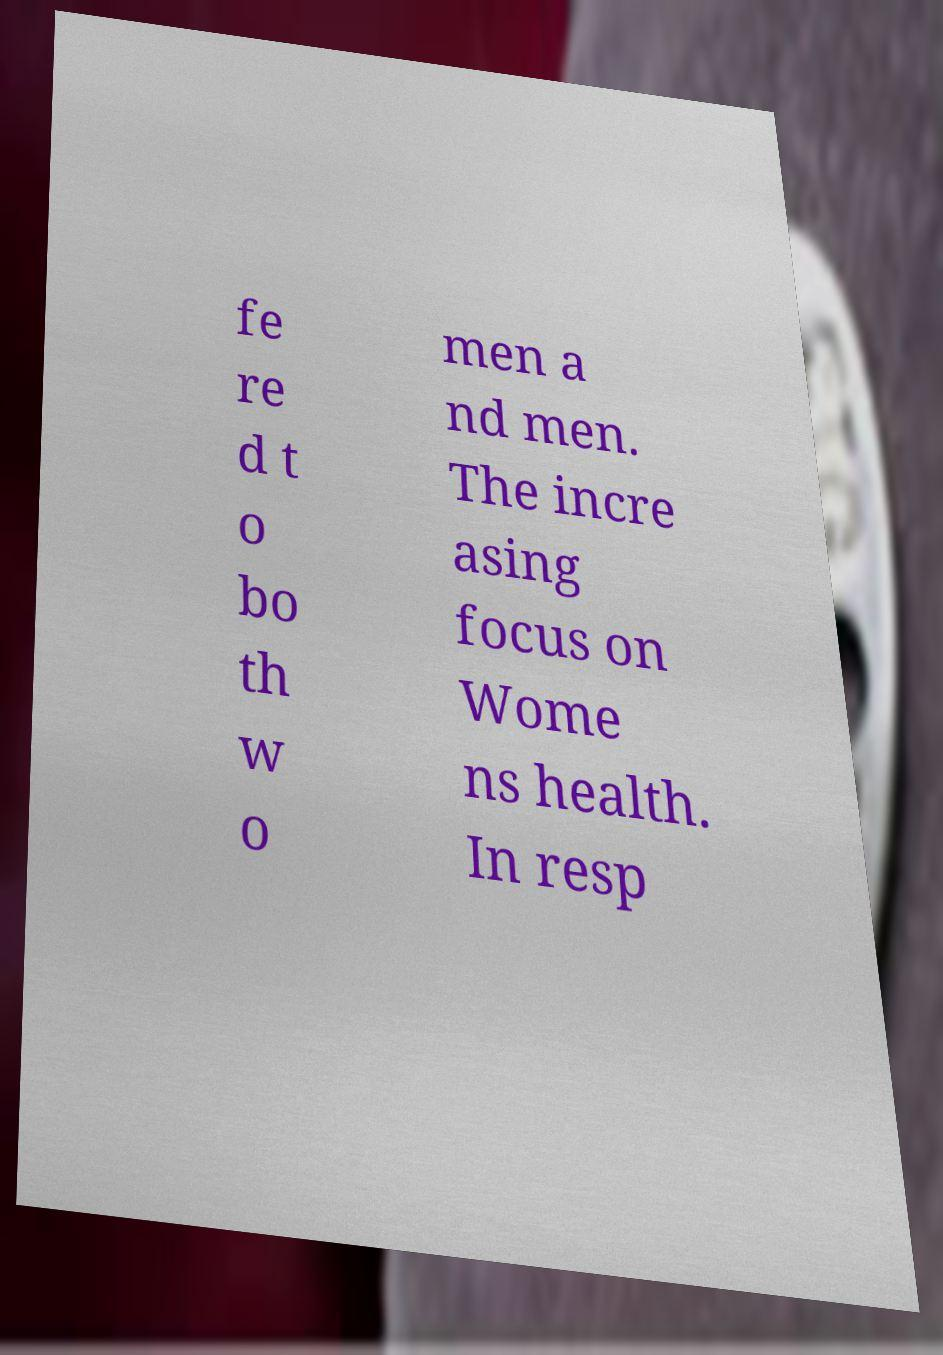There's text embedded in this image that I need extracted. Can you transcribe it verbatim? fe re d t o bo th w o men a nd men. The incre asing focus on Wome ns health. In resp 